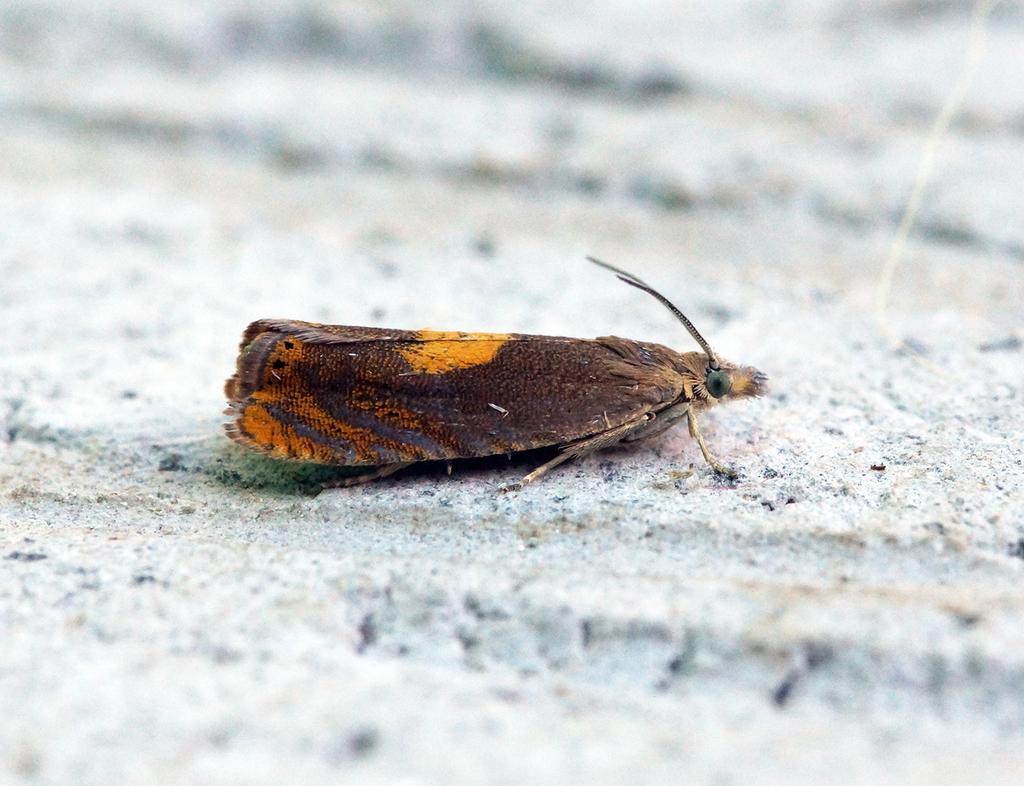Please provide a concise description of this image. In the center of the image there is a insect. 